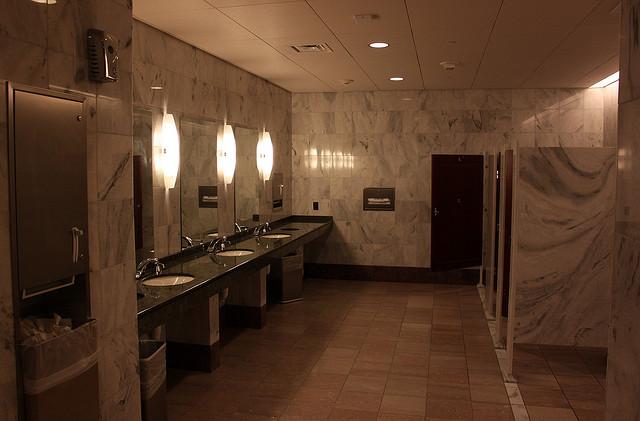Is the bathroom clean?
Concise answer only. Yes. Are there washcloths?
Quick response, please. No. How many mirrors are there?
Concise answer only. 3. What color are the tiles on the floor?
Write a very short answer. Brown. How do you know this is not a unisex bathroom?
Keep it brief. No urinals. Are the mirrors gold-plated?
Give a very brief answer. No. How many lights are shown?
Give a very brief answer. 6. How many sinks are in the bathroom?
Give a very brief answer. 3. What is the floor made of?
Give a very brief answer. Tile. What color is the tile on the wall?
Answer briefly. Gray. Is this an open room?
Quick response, please. Yes. How many sinks are in the photo?
Short answer required. 3. 